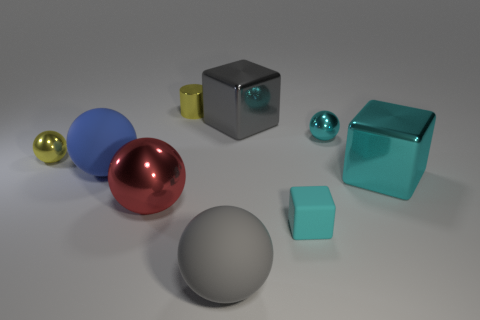Are there fewer blue balls that are in front of the large cyan metal block than small cylinders?
Keep it short and to the point. Yes. The cylinder that is the same material as the tiny cyan sphere is what color?
Provide a succinct answer. Yellow. There is a cube that is behind the large cyan cube; what size is it?
Give a very brief answer. Large. Does the big cyan thing have the same material as the large red ball?
Make the answer very short. Yes. Are there any cyan blocks behind the small sphere right of the cube to the left of the cyan rubber thing?
Provide a short and direct response. No. The large metal ball is what color?
Provide a short and direct response. Red. There is a cylinder that is the same size as the cyan ball; what is its color?
Offer a very short reply. Yellow. There is a small yellow thing to the right of the big blue ball; does it have the same shape as the large blue rubber object?
Give a very brief answer. No. The large metal object that is behind the large shiny thing that is on the right side of the big gray shiny thing to the right of the red object is what color?
Give a very brief answer. Gray. Are any small blue rubber blocks visible?
Your answer should be very brief. No. 